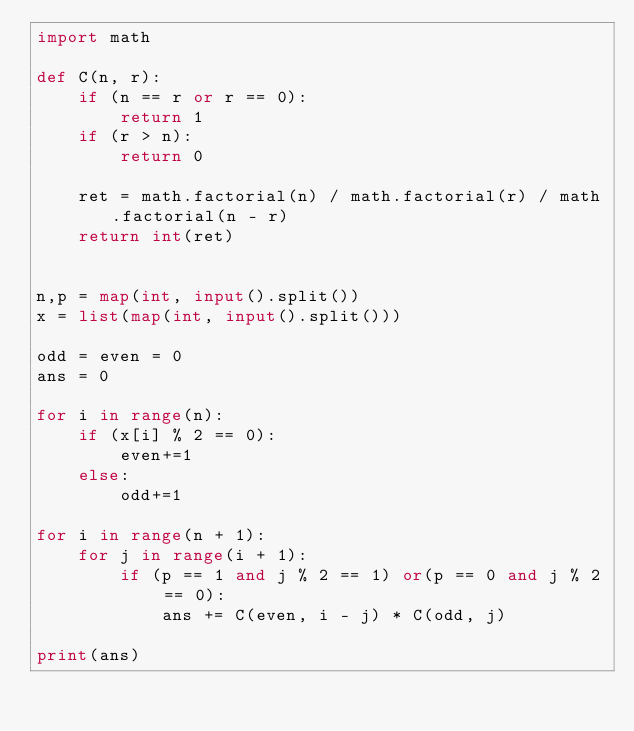Convert code to text. <code><loc_0><loc_0><loc_500><loc_500><_Python_>import math

def C(n, r):
    if (n == r or r == 0):
        return 1
    if (r > n):
        return 0

    ret = math.factorial(n) / math.factorial(r) / math.factorial(n - r)
    return int(ret)


n,p = map(int, input().split())
x = list(map(int, input().split()))

odd = even = 0
ans = 0

for i in range(n):
    if (x[i] % 2 == 0):
        even+=1
    else:
        odd+=1

for i in range(n + 1):
    for j in range(i + 1):
        if (p == 1 and j % 2 == 1) or(p == 0 and j % 2 == 0):
            ans += C(even, i - j) * C(odd, j)

print(ans)
</code> 